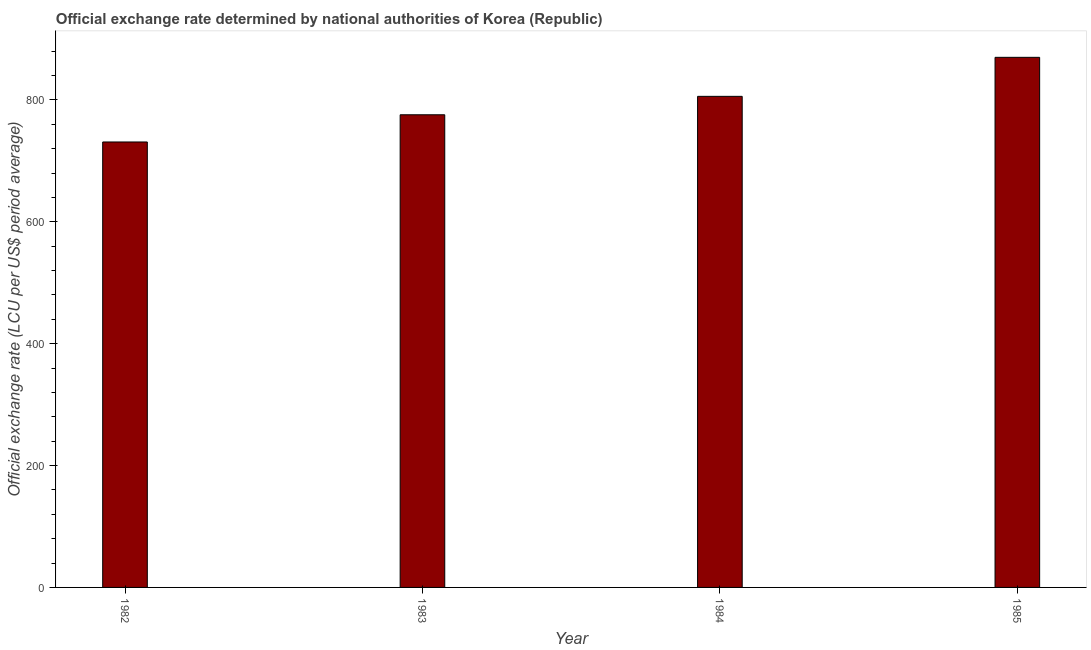Does the graph contain any zero values?
Your response must be concise. No. Does the graph contain grids?
Give a very brief answer. No. What is the title of the graph?
Provide a succinct answer. Official exchange rate determined by national authorities of Korea (Republic). What is the label or title of the X-axis?
Offer a very short reply. Year. What is the label or title of the Y-axis?
Provide a short and direct response. Official exchange rate (LCU per US$ period average). What is the official exchange rate in 1985?
Ensure brevity in your answer.  870.02. Across all years, what is the maximum official exchange rate?
Make the answer very short. 870.02. Across all years, what is the minimum official exchange rate?
Ensure brevity in your answer.  731.08. In which year was the official exchange rate maximum?
Your answer should be very brief. 1985. What is the sum of the official exchange rate?
Offer a very short reply. 3182.83. What is the difference between the official exchange rate in 1983 and 1984?
Provide a short and direct response. -30.23. What is the average official exchange rate per year?
Provide a short and direct response. 795.71. What is the median official exchange rate?
Give a very brief answer. 790.86. In how many years, is the official exchange rate greater than 200 ?
Provide a short and direct response. 4. What is the ratio of the official exchange rate in 1982 to that in 1984?
Your response must be concise. 0.91. Is the difference between the official exchange rate in 1982 and 1984 greater than the difference between any two years?
Offer a very short reply. No. What is the difference between the highest and the second highest official exchange rate?
Keep it short and to the point. 64.04. Is the sum of the official exchange rate in 1983 and 1985 greater than the maximum official exchange rate across all years?
Ensure brevity in your answer.  Yes. What is the difference between the highest and the lowest official exchange rate?
Offer a very short reply. 138.94. What is the Official exchange rate (LCU per US$ period average) in 1982?
Your answer should be compact. 731.08. What is the Official exchange rate (LCU per US$ period average) of 1983?
Your answer should be very brief. 775.75. What is the Official exchange rate (LCU per US$ period average) in 1984?
Keep it short and to the point. 805.98. What is the Official exchange rate (LCU per US$ period average) in 1985?
Give a very brief answer. 870.02. What is the difference between the Official exchange rate (LCU per US$ period average) in 1982 and 1983?
Ensure brevity in your answer.  -44.66. What is the difference between the Official exchange rate (LCU per US$ period average) in 1982 and 1984?
Your answer should be compact. -74.89. What is the difference between the Official exchange rate (LCU per US$ period average) in 1982 and 1985?
Give a very brief answer. -138.94. What is the difference between the Official exchange rate (LCU per US$ period average) in 1983 and 1984?
Give a very brief answer. -30.23. What is the difference between the Official exchange rate (LCU per US$ period average) in 1983 and 1985?
Your answer should be compact. -94.27. What is the difference between the Official exchange rate (LCU per US$ period average) in 1984 and 1985?
Your answer should be very brief. -64.04. What is the ratio of the Official exchange rate (LCU per US$ period average) in 1982 to that in 1983?
Offer a very short reply. 0.94. What is the ratio of the Official exchange rate (LCU per US$ period average) in 1982 to that in 1984?
Provide a short and direct response. 0.91. What is the ratio of the Official exchange rate (LCU per US$ period average) in 1982 to that in 1985?
Keep it short and to the point. 0.84. What is the ratio of the Official exchange rate (LCU per US$ period average) in 1983 to that in 1984?
Your answer should be very brief. 0.96. What is the ratio of the Official exchange rate (LCU per US$ period average) in 1983 to that in 1985?
Provide a succinct answer. 0.89. What is the ratio of the Official exchange rate (LCU per US$ period average) in 1984 to that in 1985?
Provide a succinct answer. 0.93. 